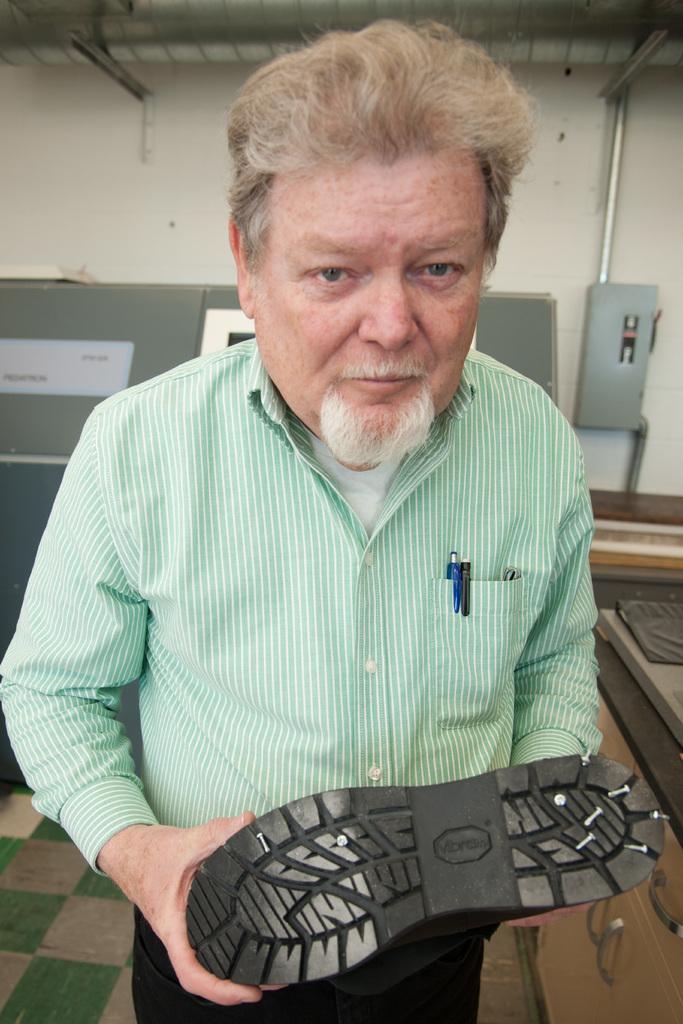Can you describe this image briefly? Here in this picture we can see an old man standing over a place and holding a shoe in his hands and behind him we can see some electrical items present on the wall and we can also see pipes and AC ducts present. 